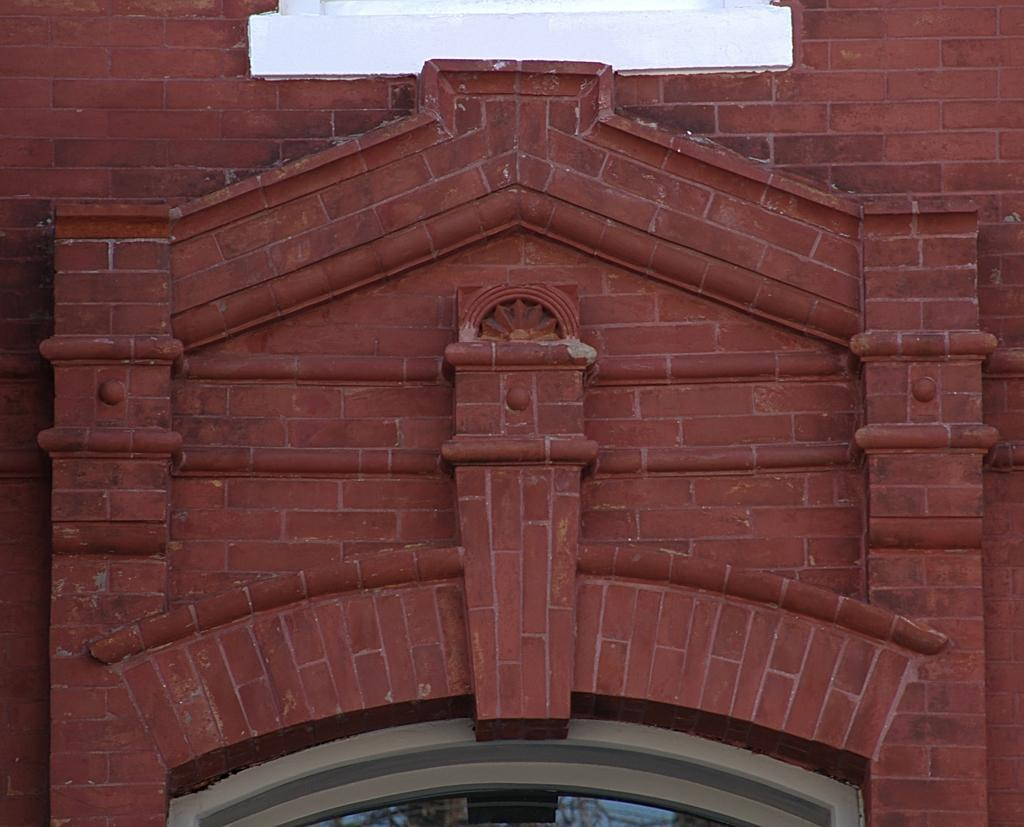Where was the image taken? The image is taken outdoors. What type of structure can be seen in the image? There is a building in the image. What is a feature of the building's exterior? The building has a wall. What is a functional element of the building? The building has a door. What type of decorative element is present on the building? The building has carvings. What type of powder is used to create the carvings on the building? There is no information about the type of powder used to create the carvings on the building. What type of magic is being performed on the building in the image? There is no indication of any magic being performed on the building in the image. 